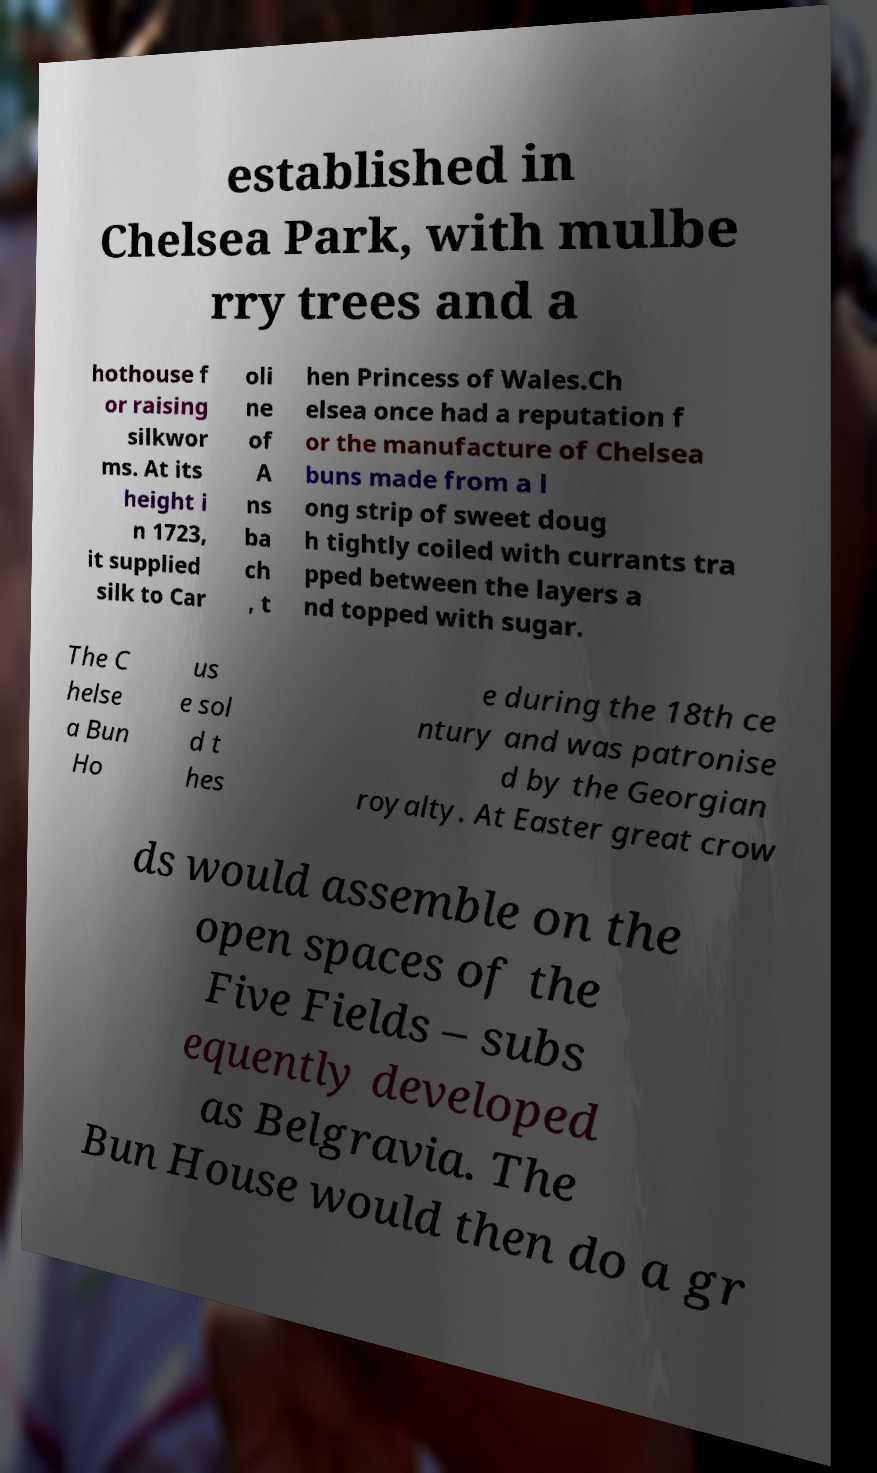What messages or text are displayed in this image? I need them in a readable, typed format. established in Chelsea Park, with mulbe rry trees and a hothouse f or raising silkwor ms. At its height i n 1723, it supplied silk to Car oli ne of A ns ba ch , t hen Princess of Wales.Ch elsea once had a reputation f or the manufacture of Chelsea buns made from a l ong strip of sweet doug h tightly coiled with currants tra pped between the layers a nd topped with sugar. The C helse a Bun Ho us e sol d t hes e during the 18th ce ntury and was patronise d by the Georgian royalty. At Easter great crow ds would assemble on the open spaces of the Five Fields – subs equently developed as Belgravia. The Bun House would then do a gr 